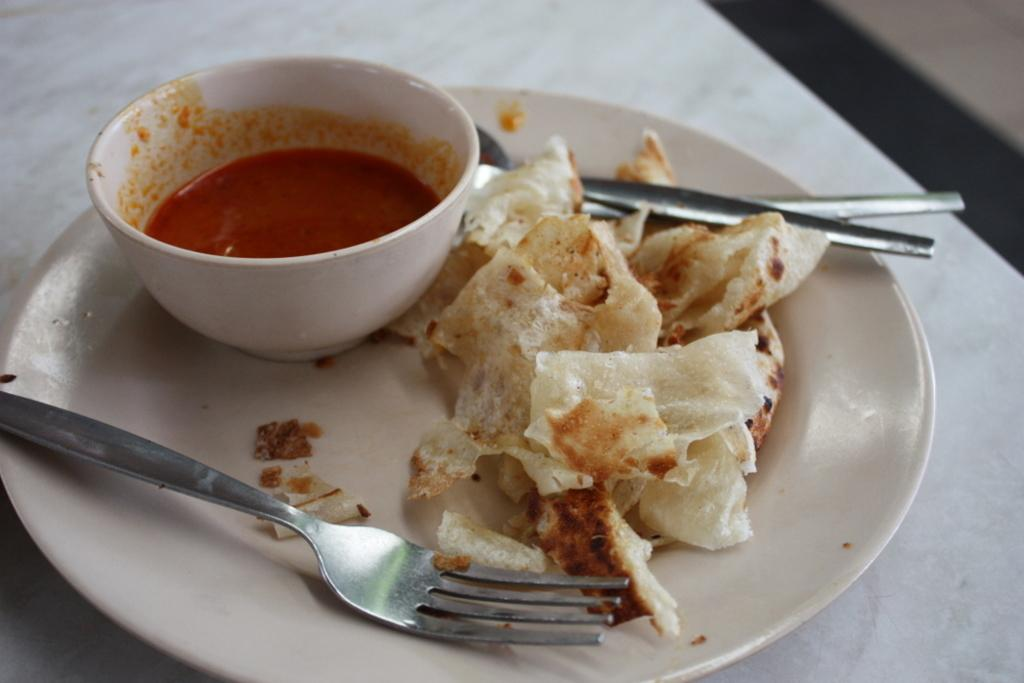What type of dishware is used to hold the food items in the image? There are food items on a white color plate in the image. What other type of dishware is present in the image? There is a bowl in the image. What utensil can be seen on the left side of the image? There is a stainless steel fork on the left side of the image. What color is the paint on the balloon in the image? There is no balloon or paint present in the image. 